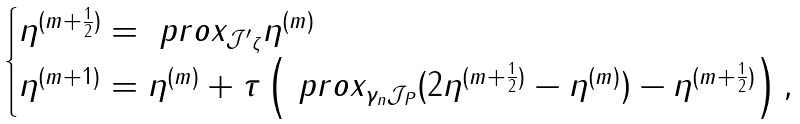<formula> <loc_0><loc_0><loc_500><loc_500>\begin{cases} \eta ^ { ( m + \frac { 1 } { 2 } ) } = \ p r o x _ { \mathcal { J ^ { \prime } } _ { \zeta } } \eta ^ { ( m ) } \\ \eta ^ { ( m + 1 ) } = \eta ^ { ( m ) } + \tau \left ( \ p r o x _ { \gamma _ { n } \mathcal { J } _ { P } } ( 2 \eta ^ { ( m + \frac { 1 } { 2 } ) } - \eta ^ { ( m ) } ) - \eta ^ { ( m + \frac { 1 } { 2 } ) } \right ) , \end{cases}</formula> 